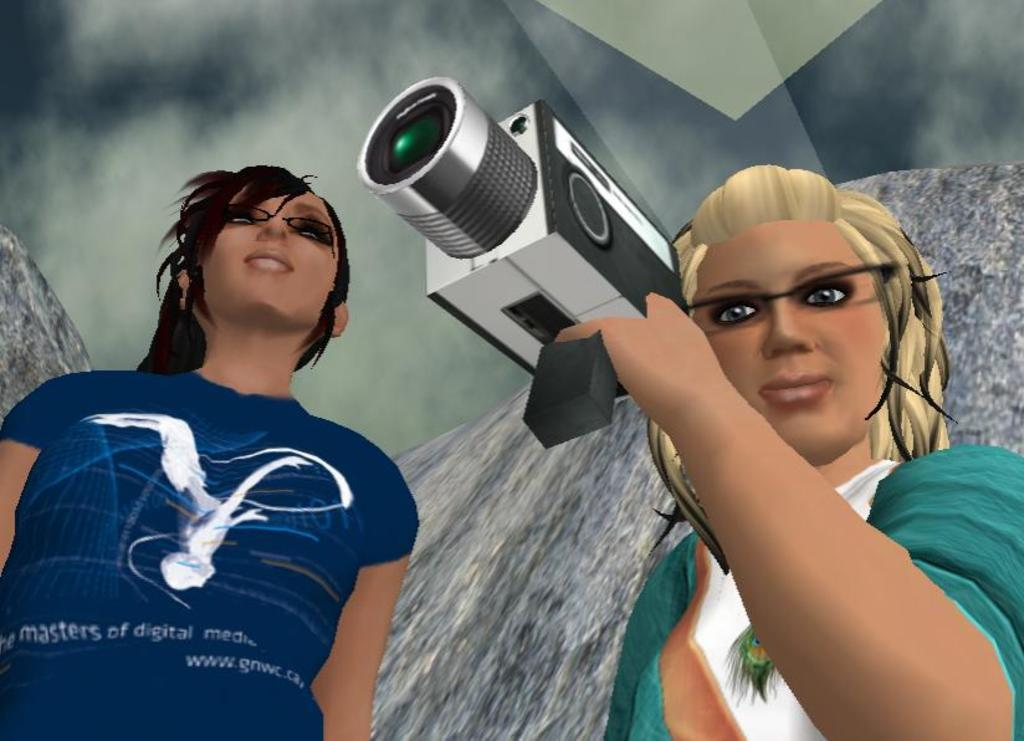What type of image is being described? The image is an animated picture. How many people are present in the image? There are two women in the image. What are the women wearing? The women are wearing spectacles. What is one of the women holding in the image? One of the women is holding a camera with her hand. How much payment is being exchanged between the women in the image? There is no indication of payment being exchanged in the image; it features two women wearing spectacles and one holding a camera. What type of pipe can be seen in the image? There is no pipe present in the image. 